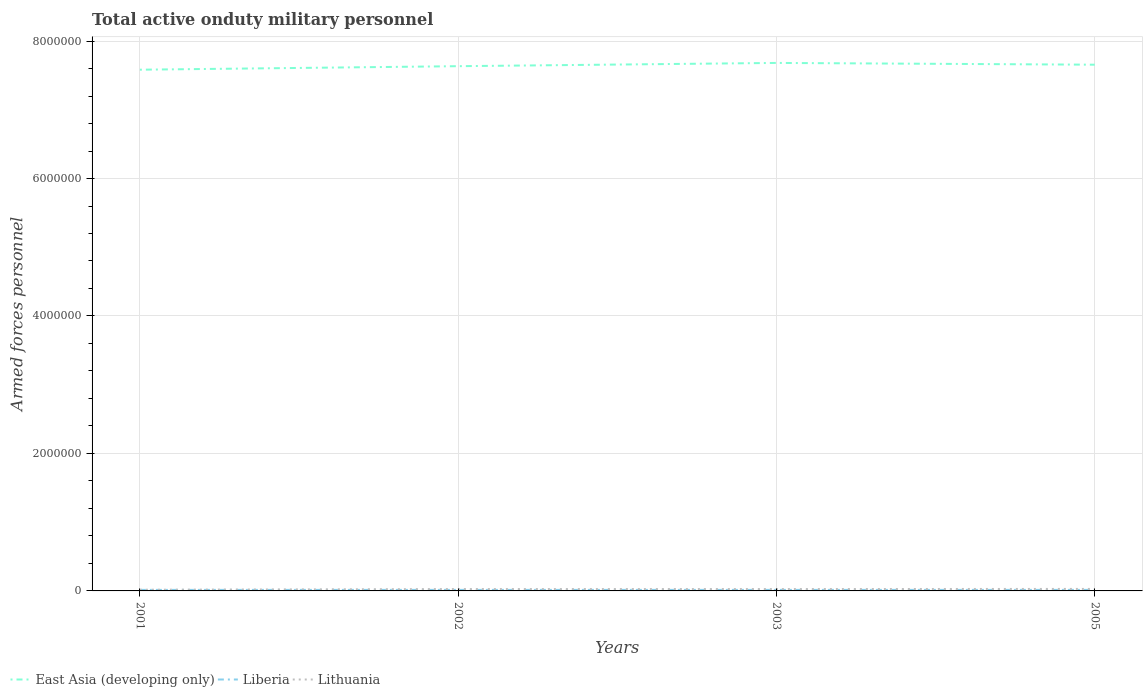Does the line corresponding to Lithuania intersect with the line corresponding to East Asia (developing only)?
Make the answer very short. No. Across all years, what is the maximum number of armed forces personnel in East Asia (developing only)?
Offer a very short reply. 7.58e+06. What is the total number of armed forces personnel in East Asia (developing only) in the graph?
Provide a short and direct response. -9.86e+04. Does the graph contain grids?
Ensure brevity in your answer.  Yes. What is the title of the graph?
Ensure brevity in your answer.  Total active onduty military personnel. What is the label or title of the X-axis?
Your answer should be very brief. Years. What is the label or title of the Y-axis?
Keep it short and to the point. Armed forces personnel. What is the Armed forces personnel of East Asia (developing only) in 2001?
Your answer should be compact. 7.58e+06. What is the Armed forces personnel in Liberia in 2001?
Keep it short and to the point. 1.50e+04. What is the Armed forces personnel in Lithuania in 2001?
Ensure brevity in your answer.  1.72e+04. What is the Armed forces personnel of East Asia (developing only) in 2002?
Offer a terse response. 7.63e+06. What is the Armed forces personnel of Liberia in 2002?
Keep it short and to the point. 1.50e+04. What is the Armed forces personnel in Lithuania in 2002?
Offer a terse response. 2.73e+04. What is the Armed forces personnel of East Asia (developing only) in 2003?
Offer a terse response. 7.68e+06. What is the Armed forces personnel of Liberia in 2003?
Keep it short and to the point. 1.50e+04. What is the Armed forces personnel of Lithuania in 2003?
Your answer should be compact. 2.73e+04. What is the Armed forces personnel in East Asia (developing only) in 2005?
Your answer should be compact. 7.66e+06. What is the Armed forces personnel in Liberia in 2005?
Give a very brief answer. 1.50e+04. What is the Armed forces personnel in Lithuania in 2005?
Your answer should be very brief. 2.90e+04. Across all years, what is the maximum Armed forces personnel in East Asia (developing only)?
Your answer should be compact. 7.68e+06. Across all years, what is the maximum Armed forces personnel in Liberia?
Offer a very short reply. 1.50e+04. Across all years, what is the maximum Armed forces personnel of Lithuania?
Your response must be concise. 2.90e+04. Across all years, what is the minimum Armed forces personnel of East Asia (developing only)?
Your answer should be compact. 7.58e+06. Across all years, what is the minimum Armed forces personnel of Liberia?
Offer a terse response. 1.50e+04. Across all years, what is the minimum Armed forces personnel of Lithuania?
Make the answer very short. 1.72e+04. What is the total Armed forces personnel in East Asia (developing only) in the graph?
Make the answer very short. 3.06e+07. What is the total Armed forces personnel in Liberia in the graph?
Make the answer very short. 6.00e+04. What is the total Armed forces personnel of Lithuania in the graph?
Make the answer very short. 1.01e+05. What is the difference between the Armed forces personnel in East Asia (developing only) in 2001 and that in 2002?
Provide a succinct answer. -5.12e+04. What is the difference between the Armed forces personnel of Liberia in 2001 and that in 2002?
Offer a terse response. 0. What is the difference between the Armed forces personnel of Lithuania in 2001 and that in 2002?
Give a very brief answer. -1.01e+04. What is the difference between the Armed forces personnel of East Asia (developing only) in 2001 and that in 2003?
Your answer should be compact. -9.86e+04. What is the difference between the Armed forces personnel of Liberia in 2001 and that in 2003?
Keep it short and to the point. 0. What is the difference between the Armed forces personnel in Lithuania in 2001 and that in 2003?
Ensure brevity in your answer.  -1.01e+04. What is the difference between the Armed forces personnel in East Asia (developing only) in 2001 and that in 2005?
Keep it short and to the point. -7.28e+04. What is the difference between the Armed forces personnel in Liberia in 2001 and that in 2005?
Offer a very short reply. 0. What is the difference between the Armed forces personnel of Lithuania in 2001 and that in 2005?
Ensure brevity in your answer.  -1.18e+04. What is the difference between the Armed forces personnel of East Asia (developing only) in 2002 and that in 2003?
Provide a short and direct response. -4.74e+04. What is the difference between the Armed forces personnel of East Asia (developing only) in 2002 and that in 2005?
Make the answer very short. -2.16e+04. What is the difference between the Armed forces personnel of Lithuania in 2002 and that in 2005?
Your answer should be very brief. -1700. What is the difference between the Armed forces personnel of East Asia (developing only) in 2003 and that in 2005?
Offer a terse response. 2.58e+04. What is the difference between the Armed forces personnel in Lithuania in 2003 and that in 2005?
Your answer should be compact. -1700. What is the difference between the Armed forces personnel of East Asia (developing only) in 2001 and the Armed forces personnel of Liberia in 2002?
Your answer should be compact. 7.57e+06. What is the difference between the Armed forces personnel of East Asia (developing only) in 2001 and the Armed forces personnel of Lithuania in 2002?
Provide a short and direct response. 7.56e+06. What is the difference between the Armed forces personnel of Liberia in 2001 and the Armed forces personnel of Lithuania in 2002?
Your response must be concise. -1.23e+04. What is the difference between the Armed forces personnel of East Asia (developing only) in 2001 and the Armed forces personnel of Liberia in 2003?
Your answer should be very brief. 7.57e+06. What is the difference between the Armed forces personnel in East Asia (developing only) in 2001 and the Armed forces personnel in Lithuania in 2003?
Your answer should be compact. 7.56e+06. What is the difference between the Armed forces personnel in Liberia in 2001 and the Armed forces personnel in Lithuania in 2003?
Your answer should be very brief. -1.23e+04. What is the difference between the Armed forces personnel in East Asia (developing only) in 2001 and the Armed forces personnel in Liberia in 2005?
Your response must be concise. 7.57e+06. What is the difference between the Armed forces personnel of East Asia (developing only) in 2001 and the Armed forces personnel of Lithuania in 2005?
Provide a succinct answer. 7.55e+06. What is the difference between the Armed forces personnel in Liberia in 2001 and the Armed forces personnel in Lithuania in 2005?
Provide a short and direct response. -1.40e+04. What is the difference between the Armed forces personnel in East Asia (developing only) in 2002 and the Armed forces personnel in Liberia in 2003?
Your response must be concise. 7.62e+06. What is the difference between the Armed forces personnel of East Asia (developing only) in 2002 and the Armed forces personnel of Lithuania in 2003?
Your response must be concise. 7.61e+06. What is the difference between the Armed forces personnel in Liberia in 2002 and the Armed forces personnel in Lithuania in 2003?
Provide a succinct answer. -1.23e+04. What is the difference between the Armed forces personnel in East Asia (developing only) in 2002 and the Armed forces personnel in Liberia in 2005?
Keep it short and to the point. 7.62e+06. What is the difference between the Armed forces personnel of East Asia (developing only) in 2002 and the Armed forces personnel of Lithuania in 2005?
Your answer should be very brief. 7.61e+06. What is the difference between the Armed forces personnel in Liberia in 2002 and the Armed forces personnel in Lithuania in 2005?
Keep it short and to the point. -1.40e+04. What is the difference between the Armed forces personnel in East Asia (developing only) in 2003 and the Armed forces personnel in Liberia in 2005?
Your answer should be compact. 7.67e+06. What is the difference between the Armed forces personnel of East Asia (developing only) in 2003 and the Armed forces personnel of Lithuania in 2005?
Provide a succinct answer. 7.65e+06. What is the difference between the Armed forces personnel of Liberia in 2003 and the Armed forces personnel of Lithuania in 2005?
Your response must be concise. -1.40e+04. What is the average Armed forces personnel in East Asia (developing only) per year?
Provide a short and direct response. 7.64e+06. What is the average Armed forces personnel in Liberia per year?
Your answer should be compact. 1.50e+04. What is the average Armed forces personnel in Lithuania per year?
Your answer should be compact. 2.52e+04. In the year 2001, what is the difference between the Armed forces personnel of East Asia (developing only) and Armed forces personnel of Liberia?
Give a very brief answer. 7.57e+06. In the year 2001, what is the difference between the Armed forces personnel of East Asia (developing only) and Armed forces personnel of Lithuania?
Provide a succinct answer. 7.57e+06. In the year 2001, what is the difference between the Armed forces personnel of Liberia and Armed forces personnel of Lithuania?
Offer a terse response. -2200. In the year 2002, what is the difference between the Armed forces personnel in East Asia (developing only) and Armed forces personnel in Liberia?
Provide a succinct answer. 7.62e+06. In the year 2002, what is the difference between the Armed forces personnel of East Asia (developing only) and Armed forces personnel of Lithuania?
Make the answer very short. 7.61e+06. In the year 2002, what is the difference between the Armed forces personnel in Liberia and Armed forces personnel in Lithuania?
Offer a very short reply. -1.23e+04. In the year 2003, what is the difference between the Armed forces personnel in East Asia (developing only) and Armed forces personnel in Liberia?
Ensure brevity in your answer.  7.67e+06. In the year 2003, what is the difference between the Armed forces personnel of East Asia (developing only) and Armed forces personnel of Lithuania?
Keep it short and to the point. 7.65e+06. In the year 2003, what is the difference between the Armed forces personnel in Liberia and Armed forces personnel in Lithuania?
Keep it short and to the point. -1.23e+04. In the year 2005, what is the difference between the Armed forces personnel of East Asia (developing only) and Armed forces personnel of Liberia?
Give a very brief answer. 7.64e+06. In the year 2005, what is the difference between the Armed forces personnel in East Asia (developing only) and Armed forces personnel in Lithuania?
Your response must be concise. 7.63e+06. In the year 2005, what is the difference between the Armed forces personnel of Liberia and Armed forces personnel of Lithuania?
Make the answer very short. -1.40e+04. What is the ratio of the Armed forces personnel of Lithuania in 2001 to that in 2002?
Make the answer very short. 0.63. What is the ratio of the Armed forces personnel of East Asia (developing only) in 2001 to that in 2003?
Your response must be concise. 0.99. What is the ratio of the Armed forces personnel in Lithuania in 2001 to that in 2003?
Offer a terse response. 0.63. What is the ratio of the Armed forces personnel in Liberia in 2001 to that in 2005?
Keep it short and to the point. 1. What is the ratio of the Armed forces personnel in Lithuania in 2001 to that in 2005?
Provide a succinct answer. 0.59. What is the ratio of the Armed forces personnel of Lithuania in 2002 to that in 2003?
Your answer should be very brief. 1. What is the ratio of the Armed forces personnel of East Asia (developing only) in 2002 to that in 2005?
Ensure brevity in your answer.  1. What is the ratio of the Armed forces personnel in Liberia in 2002 to that in 2005?
Provide a succinct answer. 1. What is the ratio of the Armed forces personnel in Lithuania in 2002 to that in 2005?
Offer a very short reply. 0.94. What is the ratio of the Armed forces personnel of Lithuania in 2003 to that in 2005?
Your answer should be very brief. 0.94. What is the difference between the highest and the second highest Armed forces personnel of East Asia (developing only)?
Your response must be concise. 2.58e+04. What is the difference between the highest and the second highest Armed forces personnel of Lithuania?
Keep it short and to the point. 1700. What is the difference between the highest and the lowest Armed forces personnel in East Asia (developing only)?
Your answer should be very brief. 9.86e+04. What is the difference between the highest and the lowest Armed forces personnel in Lithuania?
Keep it short and to the point. 1.18e+04. 